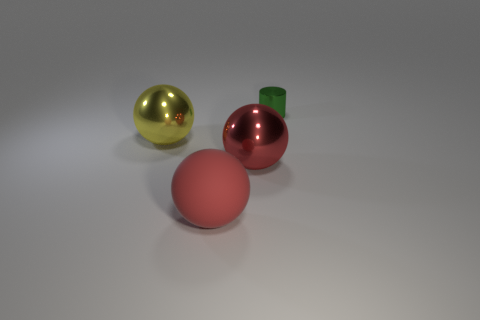Subtract all red rubber balls. How many balls are left? 2 Subtract all red blocks. How many red spheres are left? 2 Add 4 large metal things. How many objects exist? 8 Subtract all balls. How many objects are left? 1 Subtract all yellow spheres. How many spheres are left? 2 Subtract 2 spheres. How many spheres are left? 1 Add 4 large spheres. How many large spheres are left? 7 Add 2 small purple metal things. How many small purple metal things exist? 2 Subtract 1 yellow spheres. How many objects are left? 3 Subtract all gray spheres. Subtract all yellow blocks. How many spheres are left? 3 